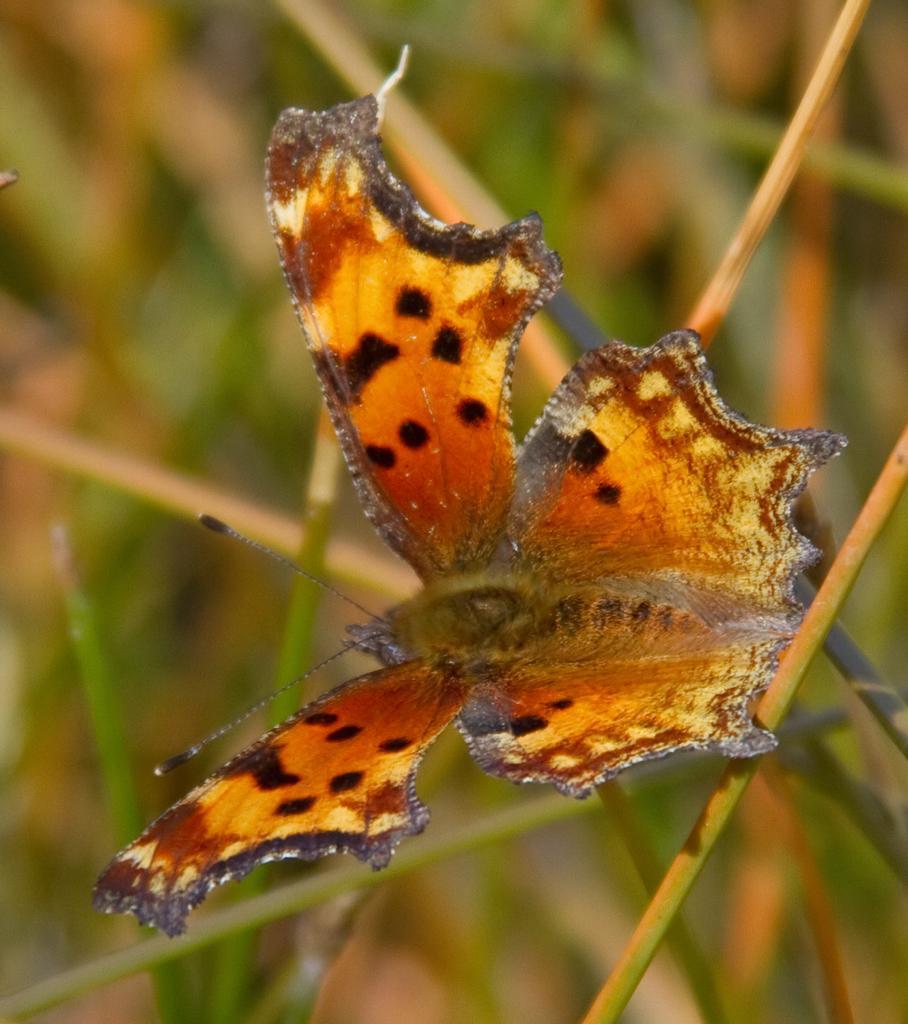Can you describe this image briefly? In this image we can see a butterfly on the grass. 